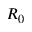Convert formula to latex. <formula><loc_0><loc_0><loc_500><loc_500>R _ { 0 }</formula> 